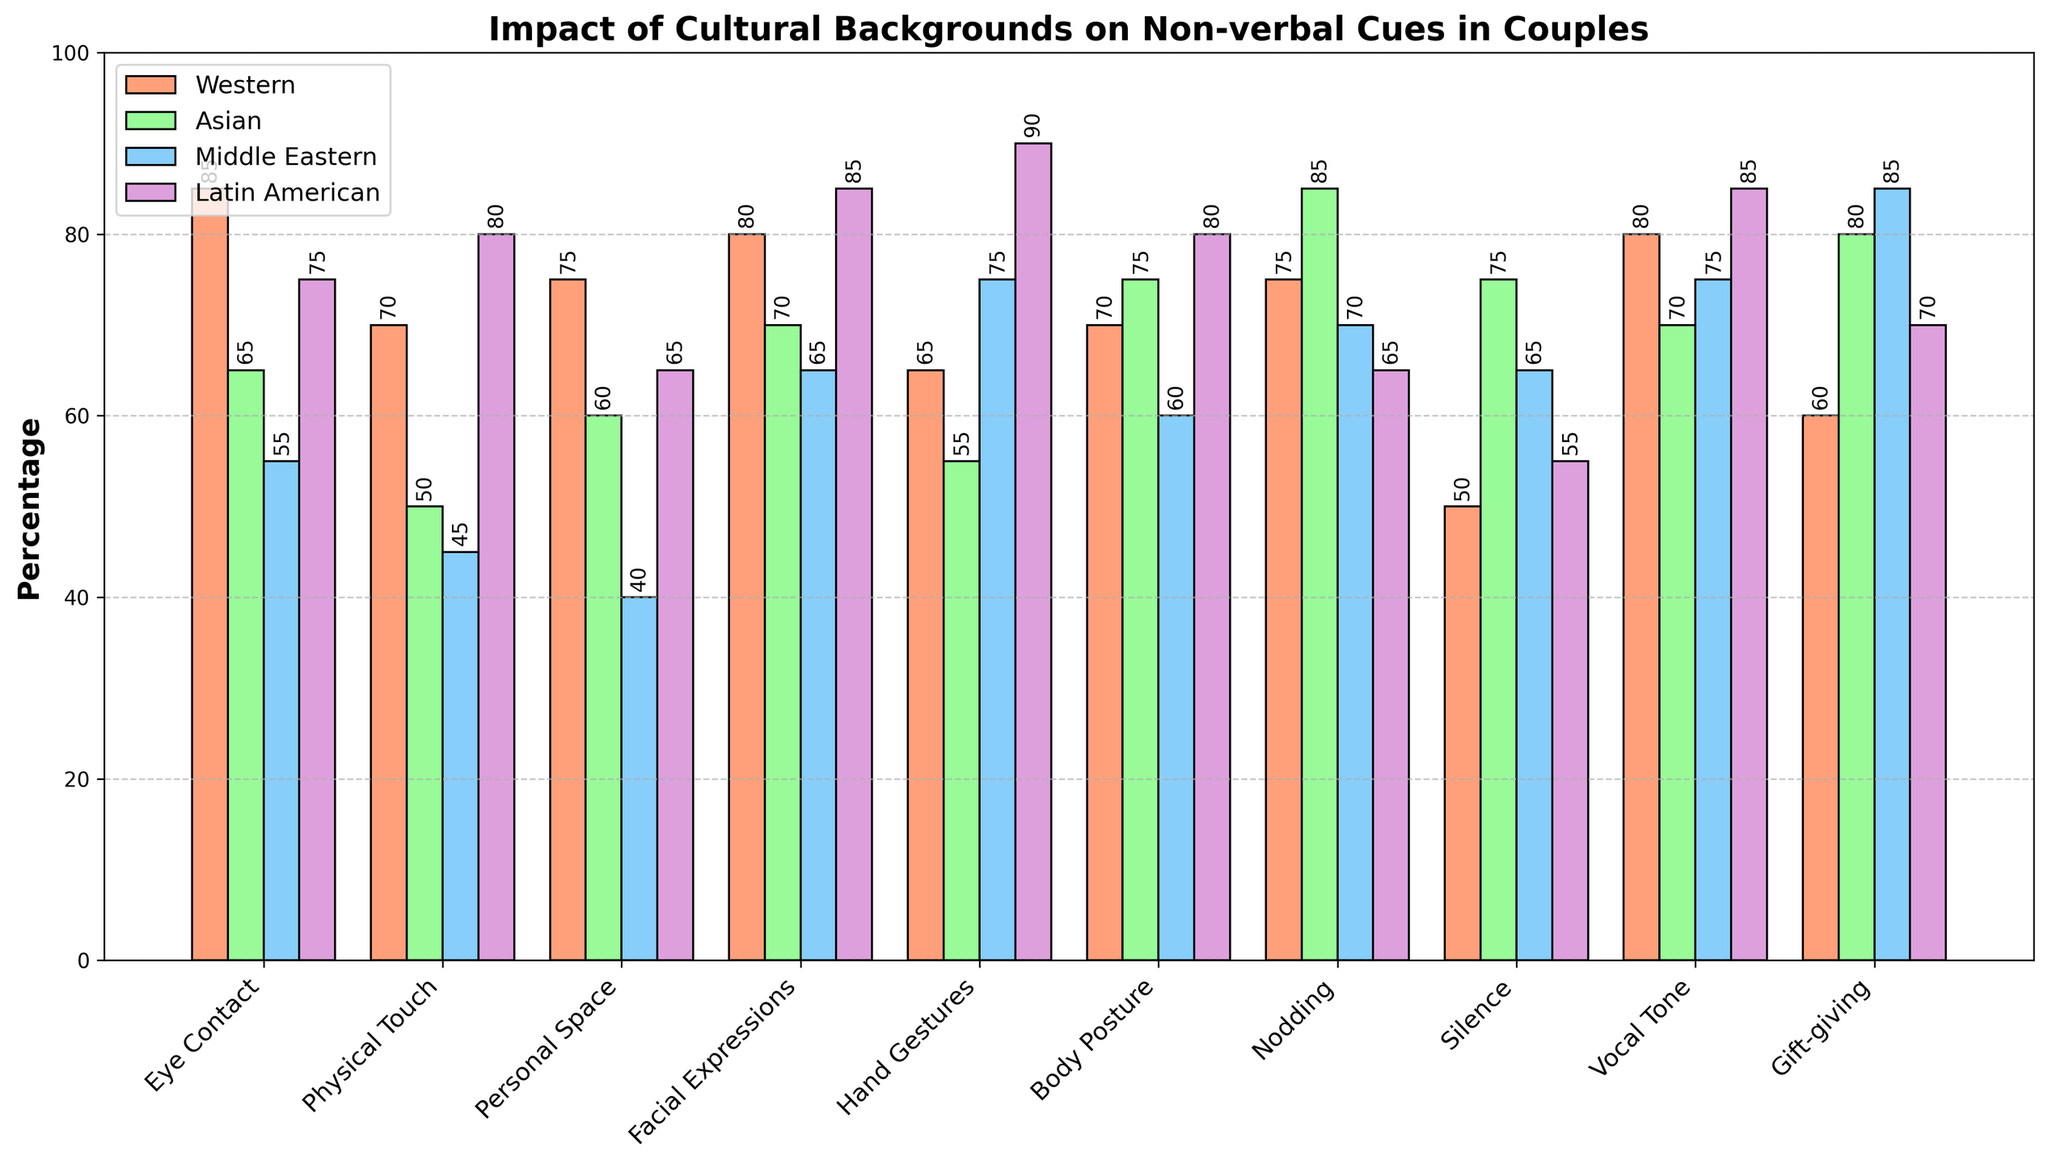Which gesture has the highest percentage for Latin American couples? Scan the Latin American column and find the gesture with the highest value. The highest percentage is 90 for Hand Gestures.
Answer: Hand Gestures Which cultural group places the most emphasis on silence as a non-verbal cue? Compare the percentages under the Silence row for each cultural group. Asian couples have the highest value of 75%.
Answer: Asian couples What is the difference in percentage between Western and Asian couples for Eye Contact? Subtract the percentage of Asian couples from Western couples for Eye Contact: 85 - 65 = 20
Answer: 20 Which gesture shows the most significant variation among the cultural groups? Calculate the range for each gesture by subtracting the minimum value from the maximum value across the cultural groups. For Physical Touch, the range is 80 - 45 = 35, which is the highest among all gestures.
Answer: Physical Touch How much higher is the percentage for nodding among Asian couples compared to Latin American couples? Subtract the value for Latin American couples from Asian couples for Nodding: 85 - 65 = 20
Answer: 20 Which cultural group has the lowest percentage for Physical Touch? In the Physical Touch row, Middle Eastern couples have the lowest percentage at 45.
Answer: Middle Eastern couples Which gesture do Western and Latin American couples have the most similar percentages? Calculate the absolute differences between percentages for each gesture between Western and Latin American couples. The smallest difference is for Facial Expressions:
Answer: Facial Expressions For which gesture do Middle Eastern couples have the highest percentage? Scan the Middle Eastern column and find the gesture with the highest value. The highest percentage is 85 for Gift-giving.
Answer: Gift-giving What is the total percentage for Eye Contact and Physical Touch among Western couples? Sum the percentages for Eye Contact and Physical Touch in Western couples: 85 + 70 = 155
Answer: 155 Which gesture shows the most variation between Western and Middle Eastern couples? Calculate the absolute differences between percentages for each gesture between Western and Middle Eastern couples. The highest difference is for Personal Space: 75 - 40 = 35
Answer: Personal Space 